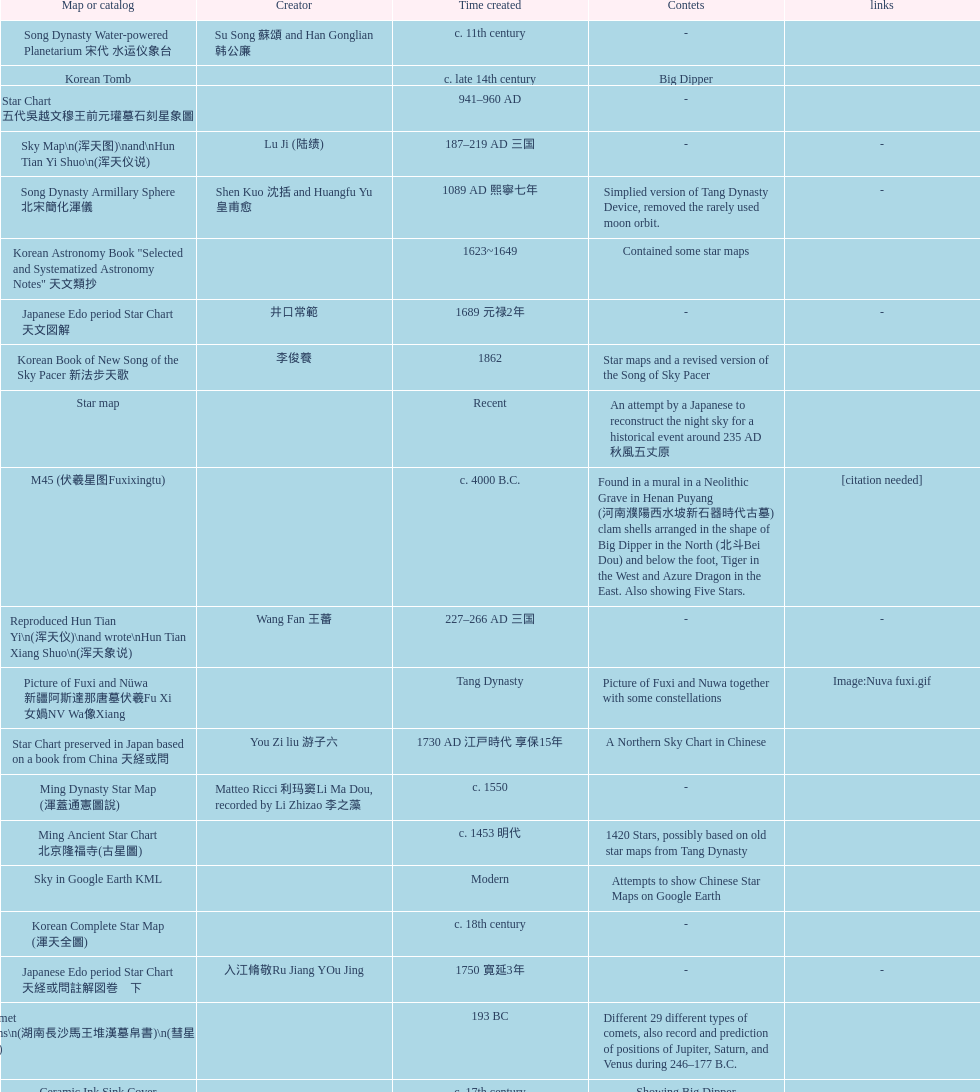Which map or catalog was created last? Sky in Google Earth KML. 